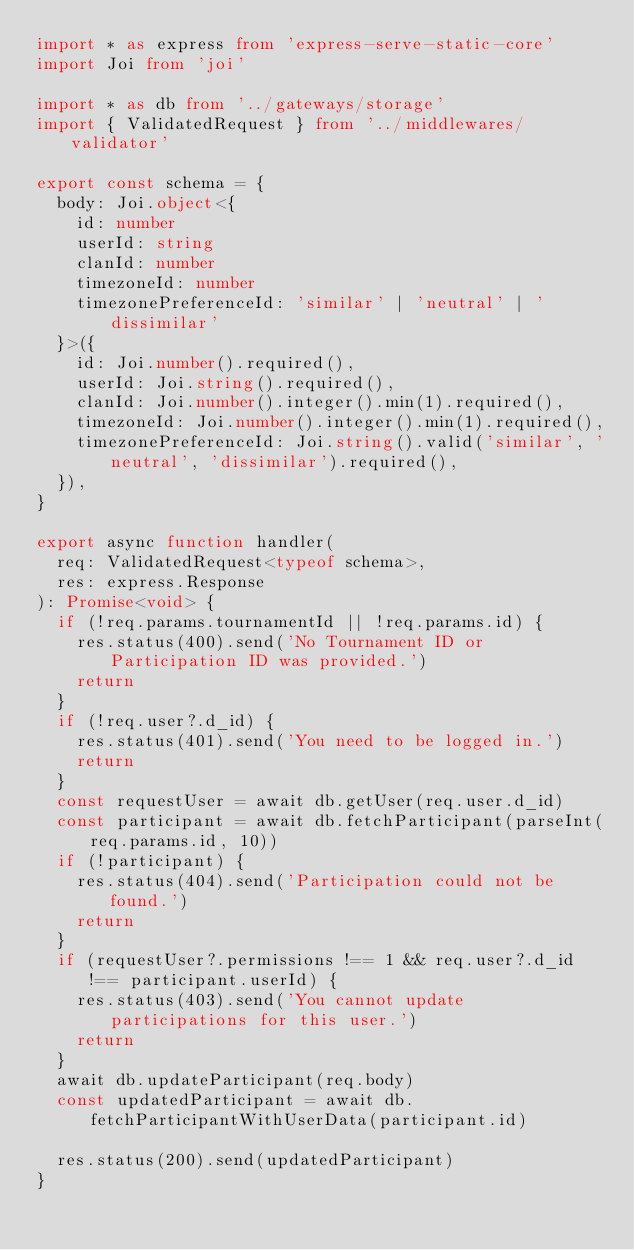<code> <loc_0><loc_0><loc_500><loc_500><_TypeScript_>import * as express from 'express-serve-static-core'
import Joi from 'joi'

import * as db from '../gateways/storage'
import { ValidatedRequest } from '../middlewares/validator'

export const schema = {
  body: Joi.object<{
    id: number
    userId: string
    clanId: number
    timezoneId: number
    timezonePreferenceId: 'similar' | 'neutral' | 'dissimilar'
  }>({
    id: Joi.number().required(),
    userId: Joi.string().required(),
    clanId: Joi.number().integer().min(1).required(),
    timezoneId: Joi.number().integer().min(1).required(),
    timezonePreferenceId: Joi.string().valid('similar', 'neutral', 'dissimilar').required(),
  }),
}

export async function handler(
  req: ValidatedRequest<typeof schema>,
  res: express.Response
): Promise<void> {
  if (!req.params.tournamentId || !req.params.id) {
    res.status(400).send('No Tournament ID or Participation ID was provided.')
    return
  }
  if (!req.user?.d_id) {
    res.status(401).send('You need to be logged in.')
    return
  }
  const requestUser = await db.getUser(req.user.d_id)
  const participant = await db.fetchParticipant(parseInt(req.params.id, 10))
  if (!participant) {
    res.status(404).send('Participation could not be found.')
    return
  }
  if (requestUser?.permissions !== 1 && req.user?.d_id !== participant.userId) {
    res.status(403).send('You cannot update participations for this user.')
    return
  }
  await db.updateParticipant(req.body)
  const updatedParticipant = await db.fetchParticipantWithUserData(participant.id)

  res.status(200).send(updatedParticipant)
}
</code> 